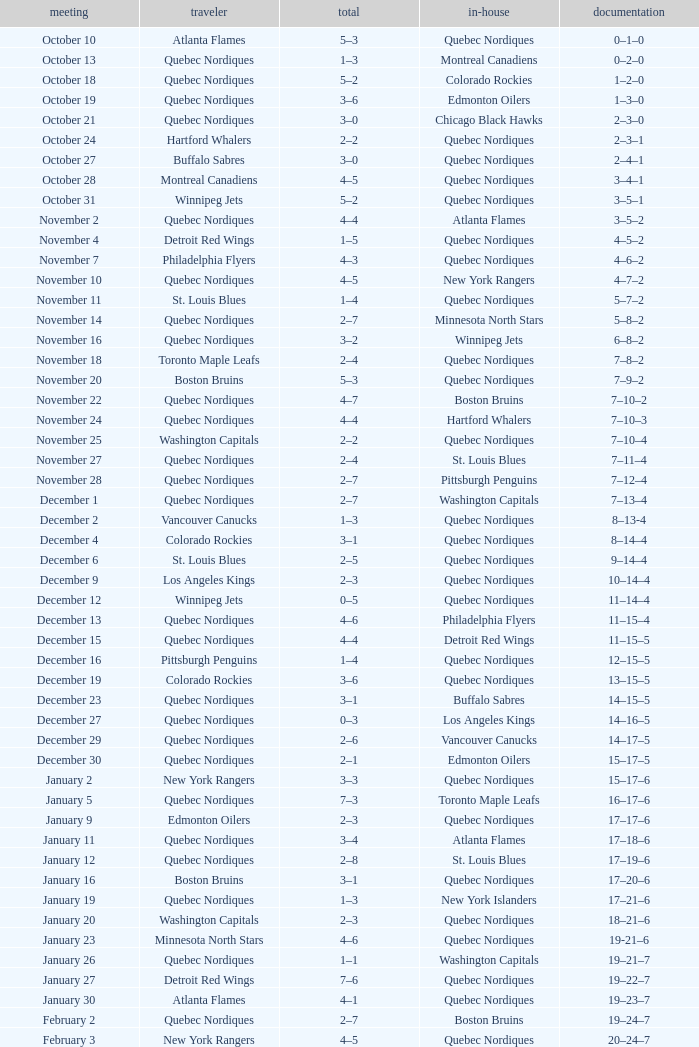Which Home has a Record of 11–14–4? Quebec Nordiques. 